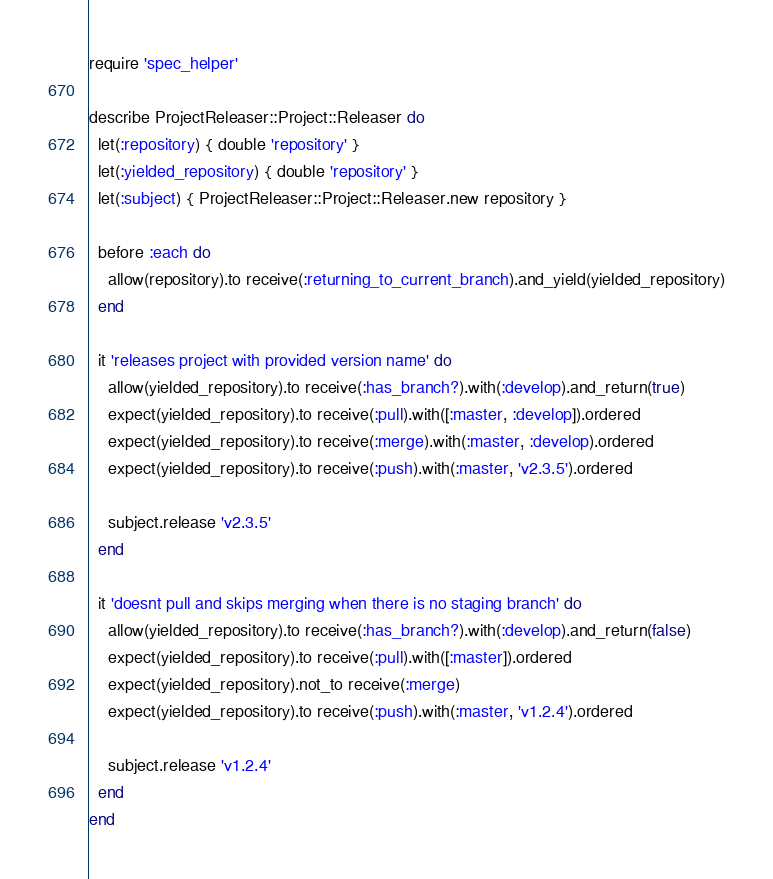Convert code to text. <code><loc_0><loc_0><loc_500><loc_500><_Ruby_>require 'spec_helper'

describe ProjectReleaser::Project::Releaser do
  let(:repository) { double 'repository' }
  let(:yielded_repository) { double 'repository' }
  let(:subject) { ProjectReleaser::Project::Releaser.new repository }

  before :each do
    allow(repository).to receive(:returning_to_current_branch).and_yield(yielded_repository)
  end

  it 'releases project with provided version name' do
    allow(yielded_repository).to receive(:has_branch?).with(:develop).and_return(true)
    expect(yielded_repository).to receive(:pull).with([:master, :develop]).ordered
    expect(yielded_repository).to receive(:merge).with(:master, :develop).ordered
    expect(yielded_repository).to receive(:push).with(:master, 'v2.3.5').ordered

    subject.release 'v2.3.5'
  end

  it 'doesnt pull and skips merging when there is no staging branch' do
    allow(yielded_repository).to receive(:has_branch?).with(:develop).and_return(false)
    expect(yielded_repository).to receive(:pull).with([:master]).ordered
    expect(yielded_repository).not_to receive(:merge)
    expect(yielded_repository).to receive(:push).with(:master, 'v1.2.4').ordered

    subject.release 'v1.2.4'
  end
end
</code> 